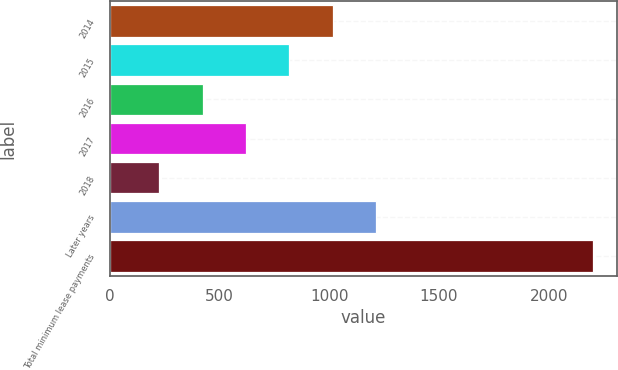<chart> <loc_0><loc_0><loc_500><loc_500><bar_chart><fcel>2014<fcel>2015<fcel>2016<fcel>2017<fcel>2018<fcel>Later years<fcel>Total minimum lease payments<nl><fcel>1015<fcel>817.5<fcel>422.5<fcel>620<fcel>225<fcel>1212.5<fcel>2200<nl></chart> 